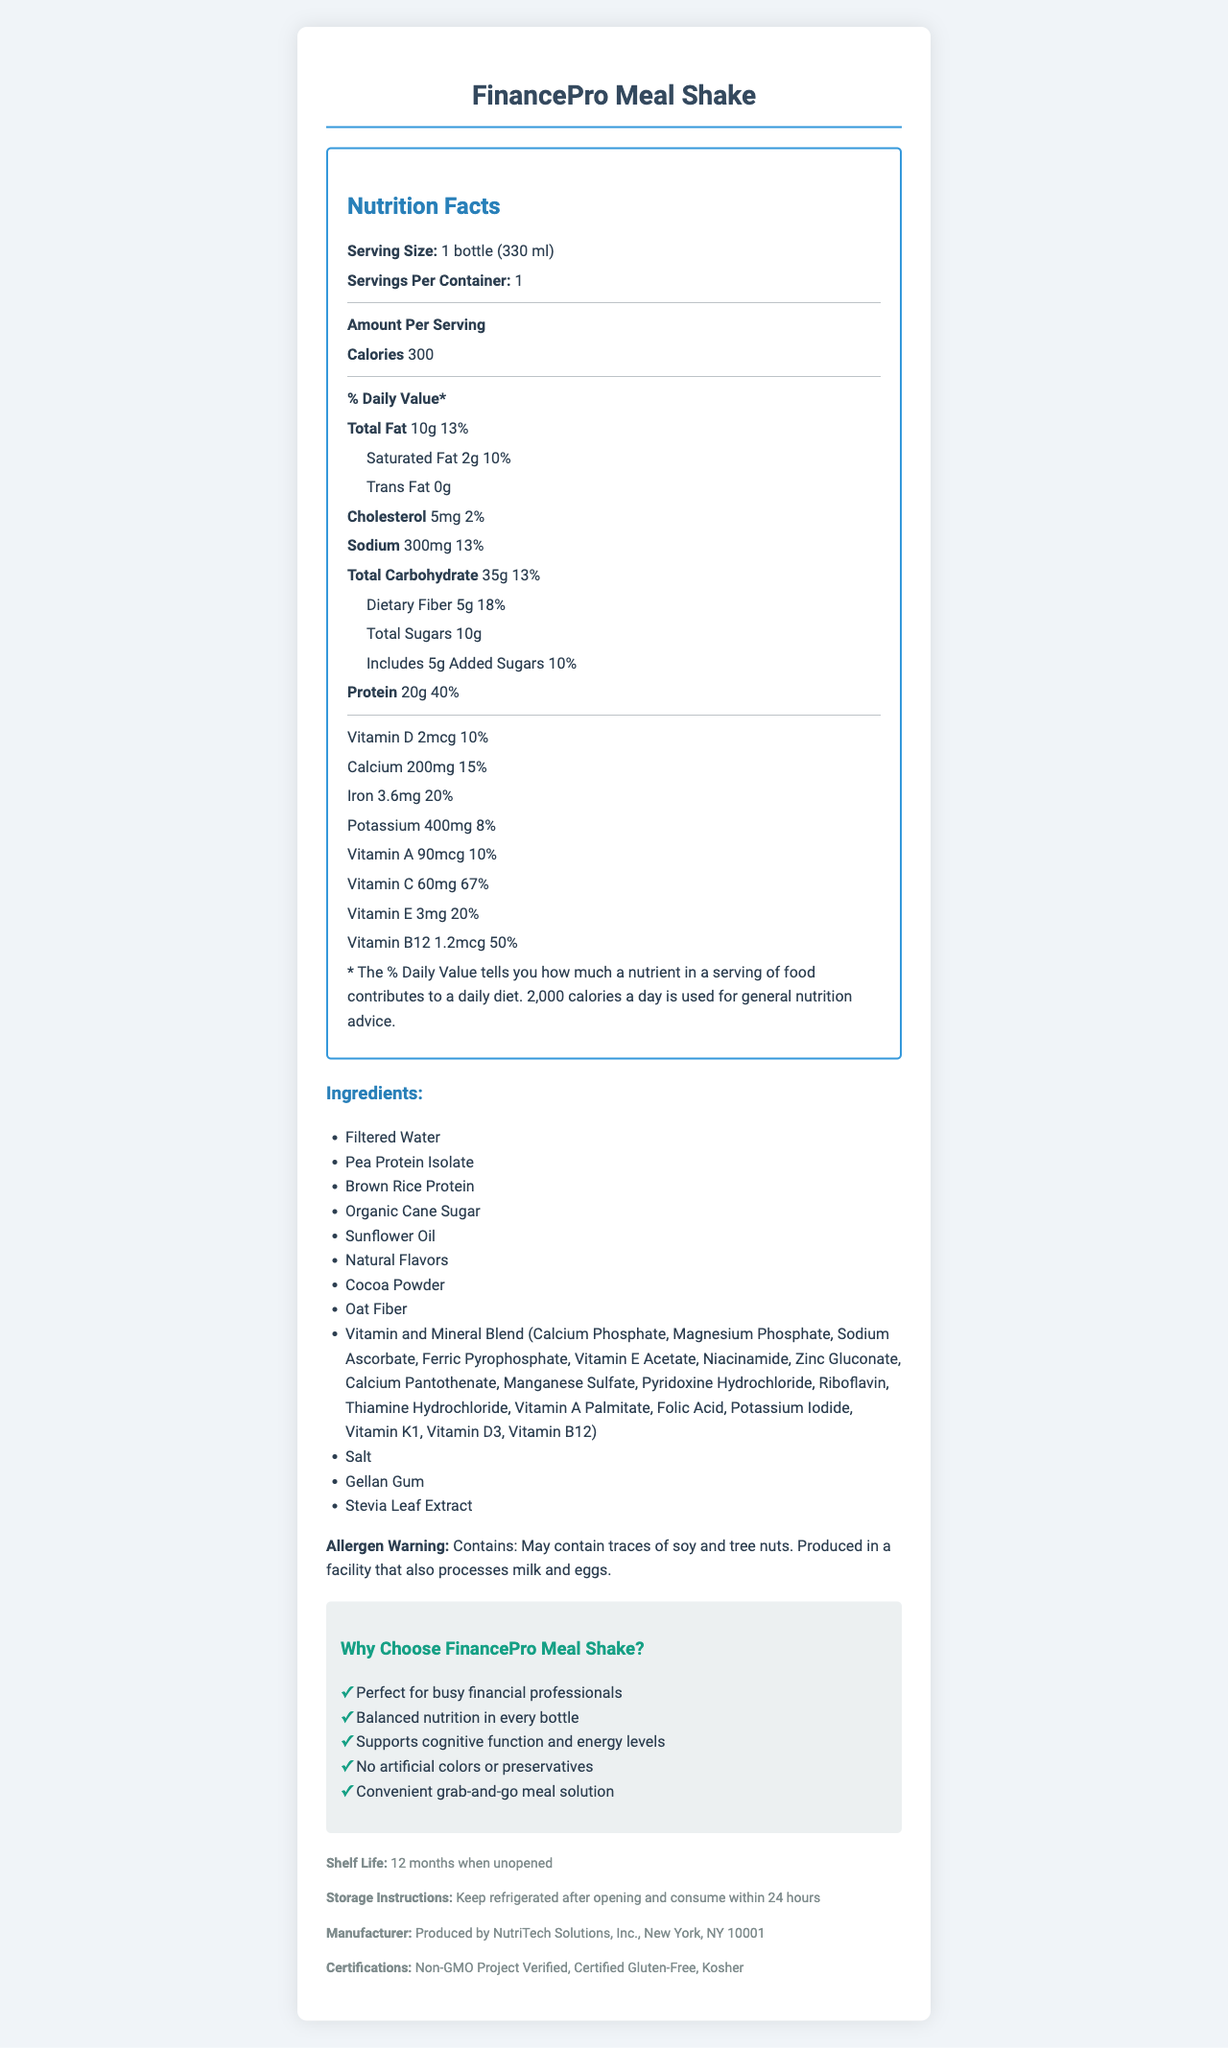what is the serving size? The serving size is explicitly stated near the top of the Nutrition Facts section.
Answer: 1 bottle (330 ml) how many calories are in one serving? Under the "Amount Per Serving" section, it mentions that there are 300 calories per serving.
Answer: 300 what is the total fat content? The total fat content is listed as 10g with a daily value of 13%.
Answer: 10g how much protein does one serving contain? The protein content is mentioned as 20g with a daily value of 40%.
Answer: 20g what vitamins and minerals are included in the Vitamin and Mineral Blend ingredient? The ingredients section lists out each component of the Vitamin and Mineral Blend.
Answer: Calcium Phosphate, Magnesium Phosphate, Sodium Ascorbate, Ferric Pyrophosphate, Vitamin E Acetate, Niacinamide, Zinc Gluconate, Calcium Pantothenate, Manganese Sulfate, Pyridoxine Hydrochloride, Riboflavin, Thiamine Hydrochloride, Vitamin A Palmitate, Folic Acid, Potassium Iodide, Vitamin K1, Vitamin D3, Vitamin B12 what is the percentage of daily value for Vitamin C? A. 10% B. 20% C. 67% D. 13% The Nutrition Facts section mentions that the daily value for Vitamin C is 67%.
Answer: C how much added sugar is in one serving? A. 2g B. 5g C. 10g D. 20g The label mentions 5g of added sugars.
Answer: B is the FinancePro Meal Shake gluten-free? A. Yes B. No C. Cannot be determined The certifications section mentions that it is Certified Gluten-Free.
Answer: A does the product contain any allergens? Yes/No The allergen warning section mentions that it may contain traces of soy and tree nuts and is produced in a facility that processes milk and eggs.
Answer: Yes summarize the main idea of the document. The entire document focuses on providing detailed nutrition information, ingredient details, marketing claims, allergen warnings, certifications, and storage instructions, making it comprehensive for potential consumers.
Answer: The document is the Nutrition Facts label for the FinancePro Meal Shake, detailing its nutritional content, ingredient list, dietary claims, allergen warnings, storage instructions, and certifications. The product is marketed as a convenient, nutritious meal solution for busy financial professionals. how much fiber does the shake have? The total carbohydrate section lists 5g of dietary fiber with an 18% daily value.
Answer: 5g how long is the shelf life of the product when unopened? The additional information section mentions that the shelf life is 12 months when unopened.
Answer: 12 months what company produces the FinancePro Meal Shake? The manufacturer information section details that it is produced by NutriTech Solutions, Inc.
Answer: NutriTech Solutions, Inc., New York, NY 10001 is the shake suitable for someone with a nut allergy? While it may contain traces of tree nuts, the document does not provide enough detailed information to definitively determine its safety for someone with a nut allergy.
Answer: Not enough information 